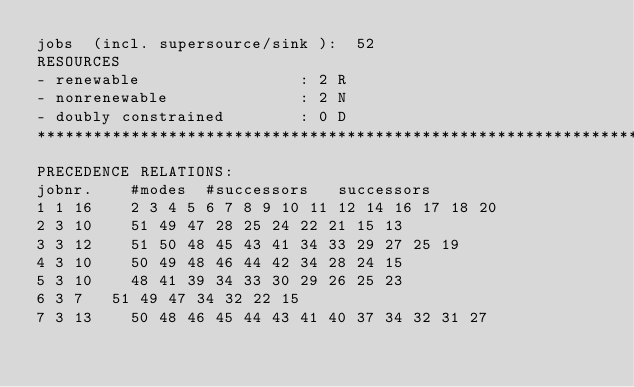<code> <loc_0><loc_0><loc_500><loc_500><_ObjectiveC_>jobs  (incl. supersource/sink ):	52
RESOURCES
- renewable                 : 2 R
- nonrenewable              : 2 N
- doubly constrained        : 0 D
************************************************************************
PRECEDENCE RELATIONS:
jobnr.    #modes  #successors   successors
1	1	16		2 3 4 5 6 7 8 9 10 11 12 14 16 17 18 20 
2	3	10		51 49 47 28 25 24 22 21 15 13 
3	3	12		51 50 48 45 43 41 34 33 29 27 25 19 
4	3	10		50 49 48 46 44 42 34 28 24 15 
5	3	10		48 41 39 34 33 30 29 26 25 23 
6	3	7		51 49 47 34 32 22 15 
7	3	13		50 48 46 45 44 43 41 40 37 34 32 31 27 </code> 